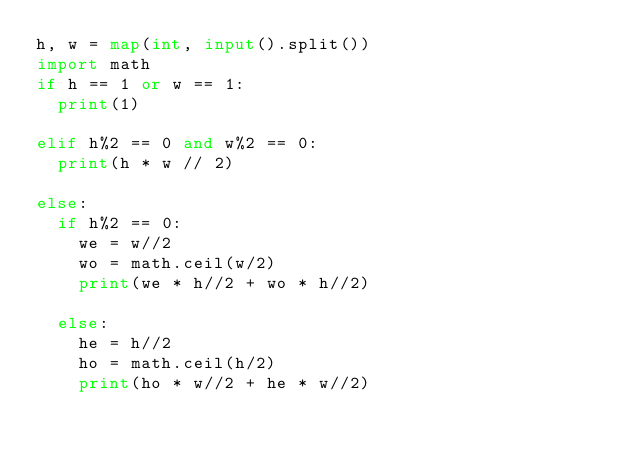<code> <loc_0><loc_0><loc_500><loc_500><_Python_>h, w = map(int, input().split())
import math
if h == 1 or w == 1:
  print(1)
  
elif h%2 == 0 and w%2 == 0:
  print(h * w // 2)
  
else:
  if h%2 == 0:
    we = w//2
    wo = math.ceil(w/2)
    print(we * h//2 + wo * h//2)
  
  else:
    he = h//2
    ho = math.ceil(h/2)
    print(ho * w//2 + he * w//2)
    
  
  </code> 